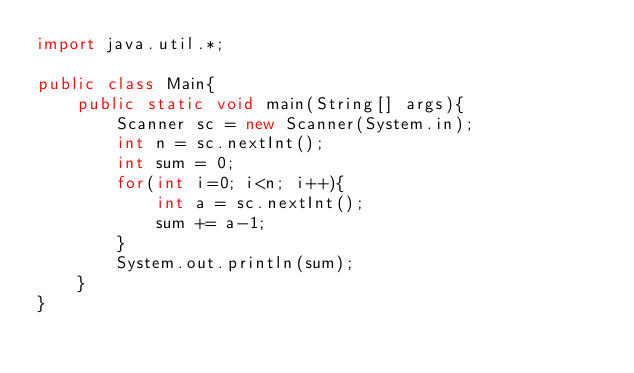Convert code to text. <code><loc_0><loc_0><loc_500><loc_500><_Java_>import java.util.*;
 
public class Main{
    public static void main(String[] args){
        Scanner sc = new Scanner(System.in);
        int n = sc.nextInt();
        int sum = 0;
        for(int i=0; i<n; i++){
            int a = sc.nextInt();
            sum += a-1;
        }
        System.out.println(sum);
    }
}</code> 